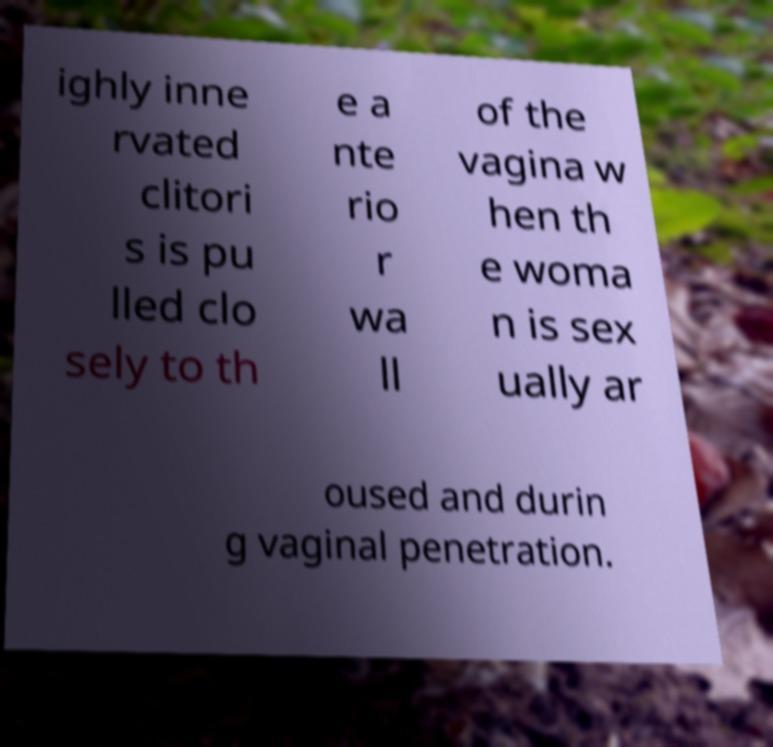Can you accurately transcribe the text from the provided image for me? ighly inne rvated clitori s is pu lled clo sely to th e a nte rio r wa ll of the vagina w hen th e woma n is sex ually ar oused and durin g vaginal penetration. 